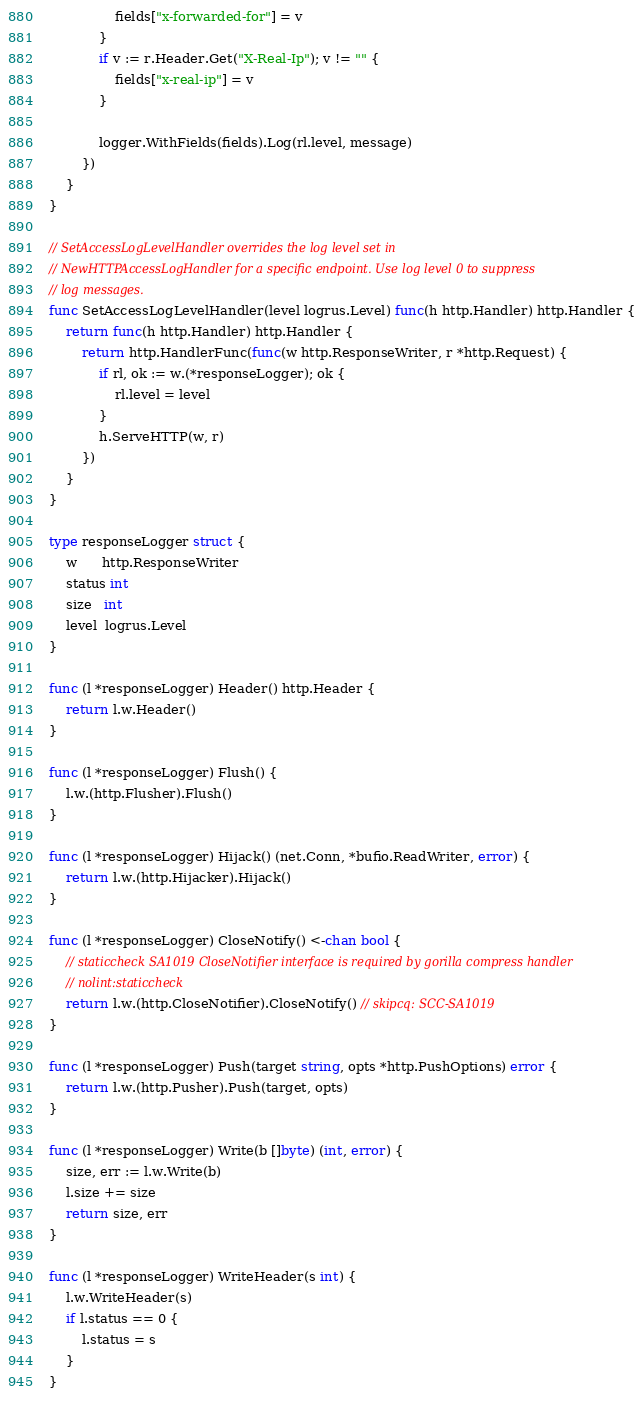Convert code to text. <code><loc_0><loc_0><loc_500><loc_500><_Go_>				fields["x-forwarded-for"] = v
			}
			if v := r.Header.Get("X-Real-Ip"); v != "" {
				fields["x-real-ip"] = v
			}

			logger.WithFields(fields).Log(rl.level, message)
		})
	}
}

// SetAccessLogLevelHandler overrides the log level set in
// NewHTTPAccessLogHandler for a specific endpoint. Use log level 0 to suppress
// log messages.
func SetAccessLogLevelHandler(level logrus.Level) func(h http.Handler) http.Handler {
	return func(h http.Handler) http.Handler {
		return http.HandlerFunc(func(w http.ResponseWriter, r *http.Request) {
			if rl, ok := w.(*responseLogger); ok {
				rl.level = level
			}
			h.ServeHTTP(w, r)
		})
	}
}

type responseLogger struct {
	w      http.ResponseWriter
	status int
	size   int
	level  logrus.Level
}

func (l *responseLogger) Header() http.Header {
	return l.w.Header()
}

func (l *responseLogger) Flush() {
	l.w.(http.Flusher).Flush()
}

func (l *responseLogger) Hijack() (net.Conn, *bufio.ReadWriter, error) {
	return l.w.(http.Hijacker).Hijack()
}

func (l *responseLogger) CloseNotify() <-chan bool {
	// staticcheck SA1019 CloseNotifier interface is required by gorilla compress handler
	// nolint:staticcheck
	return l.w.(http.CloseNotifier).CloseNotify() // skipcq: SCC-SA1019
}

func (l *responseLogger) Push(target string, opts *http.PushOptions) error {
	return l.w.(http.Pusher).Push(target, opts)
}

func (l *responseLogger) Write(b []byte) (int, error) {
	size, err := l.w.Write(b)
	l.size += size
	return size, err
}

func (l *responseLogger) WriteHeader(s int) {
	l.w.WriteHeader(s)
	if l.status == 0 {
		l.status = s
	}
}
</code> 